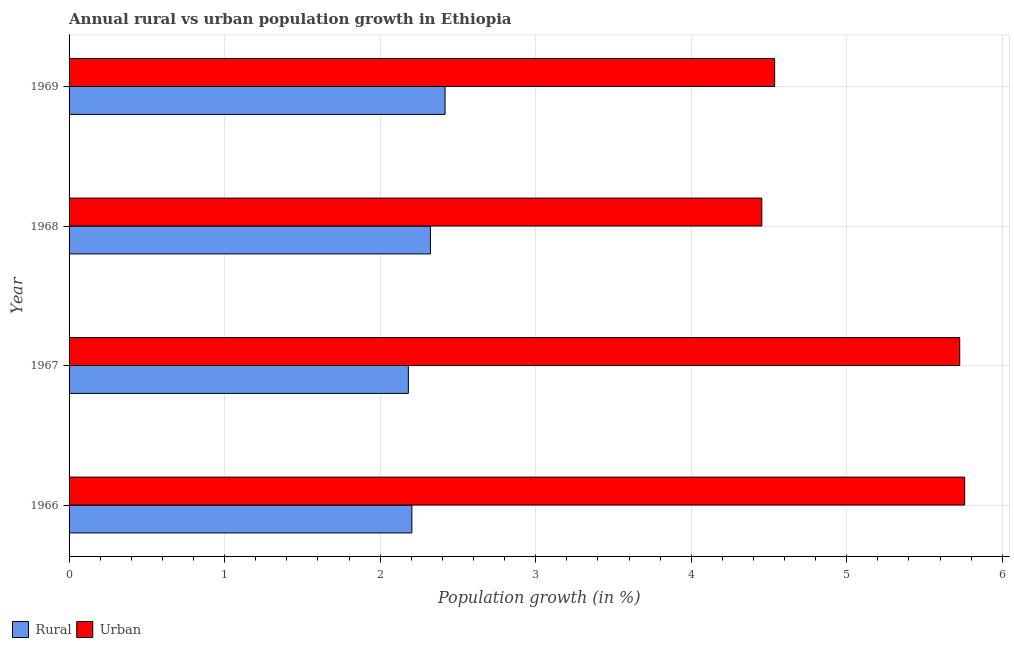How many different coloured bars are there?
Your answer should be compact. 2. How many bars are there on the 4th tick from the top?
Your answer should be very brief. 2. What is the label of the 4th group of bars from the top?
Give a very brief answer. 1966. In how many cases, is the number of bars for a given year not equal to the number of legend labels?
Give a very brief answer. 0. What is the urban population growth in 1967?
Offer a very short reply. 5.73. Across all years, what is the maximum urban population growth?
Give a very brief answer. 5.76. Across all years, what is the minimum urban population growth?
Your response must be concise. 4.45. In which year was the rural population growth maximum?
Ensure brevity in your answer.  1969. In which year was the rural population growth minimum?
Offer a terse response. 1967. What is the total urban population growth in the graph?
Keep it short and to the point. 20.48. What is the difference between the rural population growth in 1966 and that in 1968?
Your answer should be compact. -0.12. What is the difference between the rural population growth in 1969 and the urban population growth in 1966?
Provide a succinct answer. -3.34. What is the average urban population growth per year?
Provide a succinct answer. 5.12. In the year 1967, what is the difference between the rural population growth and urban population growth?
Your answer should be very brief. -3.54. What is the ratio of the rural population growth in 1966 to that in 1968?
Your answer should be compact. 0.95. What is the difference between the highest and the second highest urban population growth?
Offer a terse response. 0.03. What is the difference between the highest and the lowest rural population growth?
Your answer should be very brief. 0.24. Is the sum of the rural population growth in 1966 and 1969 greater than the maximum urban population growth across all years?
Give a very brief answer. No. What does the 2nd bar from the top in 1966 represents?
Your answer should be very brief. Rural. What does the 2nd bar from the bottom in 1966 represents?
Your answer should be very brief. Urban . How many years are there in the graph?
Your response must be concise. 4. Where does the legend appear in the graph?
Provide a succinct answer. Bottom left. What is the title of the graph?
Offer a very short reply. Annual rural vs urban population growth in Ethiopia. What is the label or title of the X-axis?
Keep it short and to the point. Population growth (in %). What is the Population growth (in %) of Rural in 1966?
Your answer should be very brief. 2.2. What is the Population growth (in %) in Urban  in 1966?
Your response must be concise. 5.76. What is the Population growth (in %) of Rural in 1967?
Your answer should be very brief. 2.18. What is the Population growth (in %) of Urban  in 1967?
Your response must be concise. 5.73. What is the Population growth (in %) in Rural in 1968?
Provide a short and direct response. 2.32. What is the Population growth (in %) of Urban  in 1968?
Keep it short and to the point. 4.45. What is the Population growth (in %) in Rural in 1969?
Provide a short and direct response. 2.42. What is the Population growth (in %) of Urban  in 1969?
Your answer should be compact. 4.54. Across all years, what is the maximum Population growth (in %) in Rural?
Give a very brief answer. 2.42. Across all years, what is the maximum Population growth (in %) in Urban ?
Provide a short and direct response. 5.76. Across all years, what is the minimum Population growth (in %) of Rural?
Your answer should be compact. 2.18. Across all years, what is the minimum Population growth (in %) of Urban ?
Offer a terse response. 4.45. What is the total Population growth (in %) of Rural in the graph?
Provide a succinct answer. 9.13. What is the total Population growth (in %) of Urban  in the graph?
Offer a terse response. 20.48. What is the difference between the Population growth (in %) of Rural in 1966 and that in 1967?
Your answer should be very brief. 0.02. What is the difference between the Population growth (in %) of Urban  in 1966 and that in 1967?
Ensure brevity in your answer.  0.03. What is the difference between the Population growth (in %) of Rural in 1966 and that in 1968?
Keep it short and to the point. -0.12. What is the difference between the Population growth (in %) in Urban  in 1966 and that in 1968?
Provide a short and direct response. 1.3. What is the difference between the Population growth (in %) in Rural in 1966 and that in 1969?
Offer a terse response. -0.21. What is the difference between the Population growth (in %) of Urban  in 1966 and that in 1969?
Your response must be concise. 1.22. What is the difference between the Population growth (in %) of Rural in 1967 and that in 1968?
Keep it short and to the point. -0.14. What is the difference between the Population growth (in %) of Urban  in 1967 and that in 1968?
Offer a terse response. 1.27. What is the difference between the Population growth (in %) of Rural in 1967 and that in 1969?
Your response must be concise. -0.24. What is the difference between the Population growth (in %) in Urban  in 1967 and that in 1969?
Provide a short and direct response. 1.19. What is the difference between the Population growth (in %) of Rural in 1968 and that in 1969?
Your response must be concise. -0.09. What is the difference between the Population growth (in %) in Urban  in 1968 and that in 1969?
Keep it short and to the point. -0.08. What is the difference between the Population growth (in %) of Rural in 1966 and the Population growth (in %) of Urban  in 1967?
Provide a short and direct response. -3.52. What is the difference between the Population growth (in %) in Rural in 1966 and the Population growth (in %) in Urban  in 1968?
Your answer should be very brief. -2.25. What is the difference between the Population growth (in %) in Rural in 1966 and the Population growth (in %) in Urban  in 1969?
Keep it short and to the point. -2.33. What is the difference between the Population growth (in %) in Rural in 1967 and the Population growth (in %) in Urban  in 1968?
Your response must be concise. -2.27. What is the difference between the Population growth (in %) of Rural in 1967 and the Population growth (in %) of Urban  in 1969?
Offer a very short reply. -2.36. What is the difference between the Population growth (in %) of Rural in 1968 and the Population growth (in %) of Urban  in 1969?
Keep it short and to the point. -2.21. What is the average Population growth (in %) of Rural per year?
Ensure brevity in your answer.  2.28. What is the average Population growth (in %) of Urban  per year?
Your answer should be compact. 5.12. In the year 1966, what is the difference between the Population growth (in %) in Rural and Population growth (in %) in Urban ?
Your answer should be compact. -3.55. In the year 1967, what is the difference between the Population growth (in %) in Rural and Population growth (in %) in Urban ?
Make the answer very short. -3.54. In the year 1968, what is the difference between the Population growth (in %) in Rural and Population growth (in %) in Urban ?
Provide a succinct answer. -2.13. In the year 1969, what is the difference between the Population growth (in %) in Rural and Population growth (in %) in Urban ?
Offer a terse response. -2.12. What is the ratio of the Population growth (in %) in Rural in 1966 to that in 1967?
Offer a terse response. 1.01. What is the ratio of the Population growth (in %) in Urban  in 1966 to that in 1967?
Provide a short and direct response. 1.01. What is the ratio of the Population growth (in %) in Rural in 1966 to that in 1968?
Provide a short and direct response. 0.95. What is the ratio of the Population growth (in %) of Urban  in 1966 to that in 1968?
Make the answer very short. 1.29. What is the ratio of the Population growth (in %) in Rural in 1966 to that in 1969?
Offer a very short reply. 0.91. What is the ratio of the Population growth (in %) in Urban  in 1966 to that in 1969?
Provide a succinct answer. 1.27. What is the ratio of the Population growth (in %) in Rural in 1967 to that in 1968?
Offer a terse response. 0.94. What is the ratio of the Population growth (in %) of Rural in 1967 to that in 1969?
Your answer should be very brief. 0.9. What is the ratio of the Population growth (in %) of Urban  in 1967 to that in 1969?
Ensure brevity in your answer.  1.26. What is the ratio of the Population growth (in %) in Rural in 1968 to that in 1969?
Make the answer very short. 0.96. What is the ratio of the Population growth (in %) of Urban  in 1968 to that in 1969?
Make the answer very short. 0.98. What is the difference between the highest and the second highest Population growth (in %) of Rural?
Keep it short and to the point. 0.09. What is the difference between the highest and the second highest Population growth (in %) of Urban ?
Provide a short and direct response. 0.03. What is the difference between the highest and the lowest Population growth (in %) of Rural?
Provide a short and direct response. 0.24. What is the difference between the highest and the lowest Population growth (in %) in Urban ?
Keep it short and to the point. 1.3. 